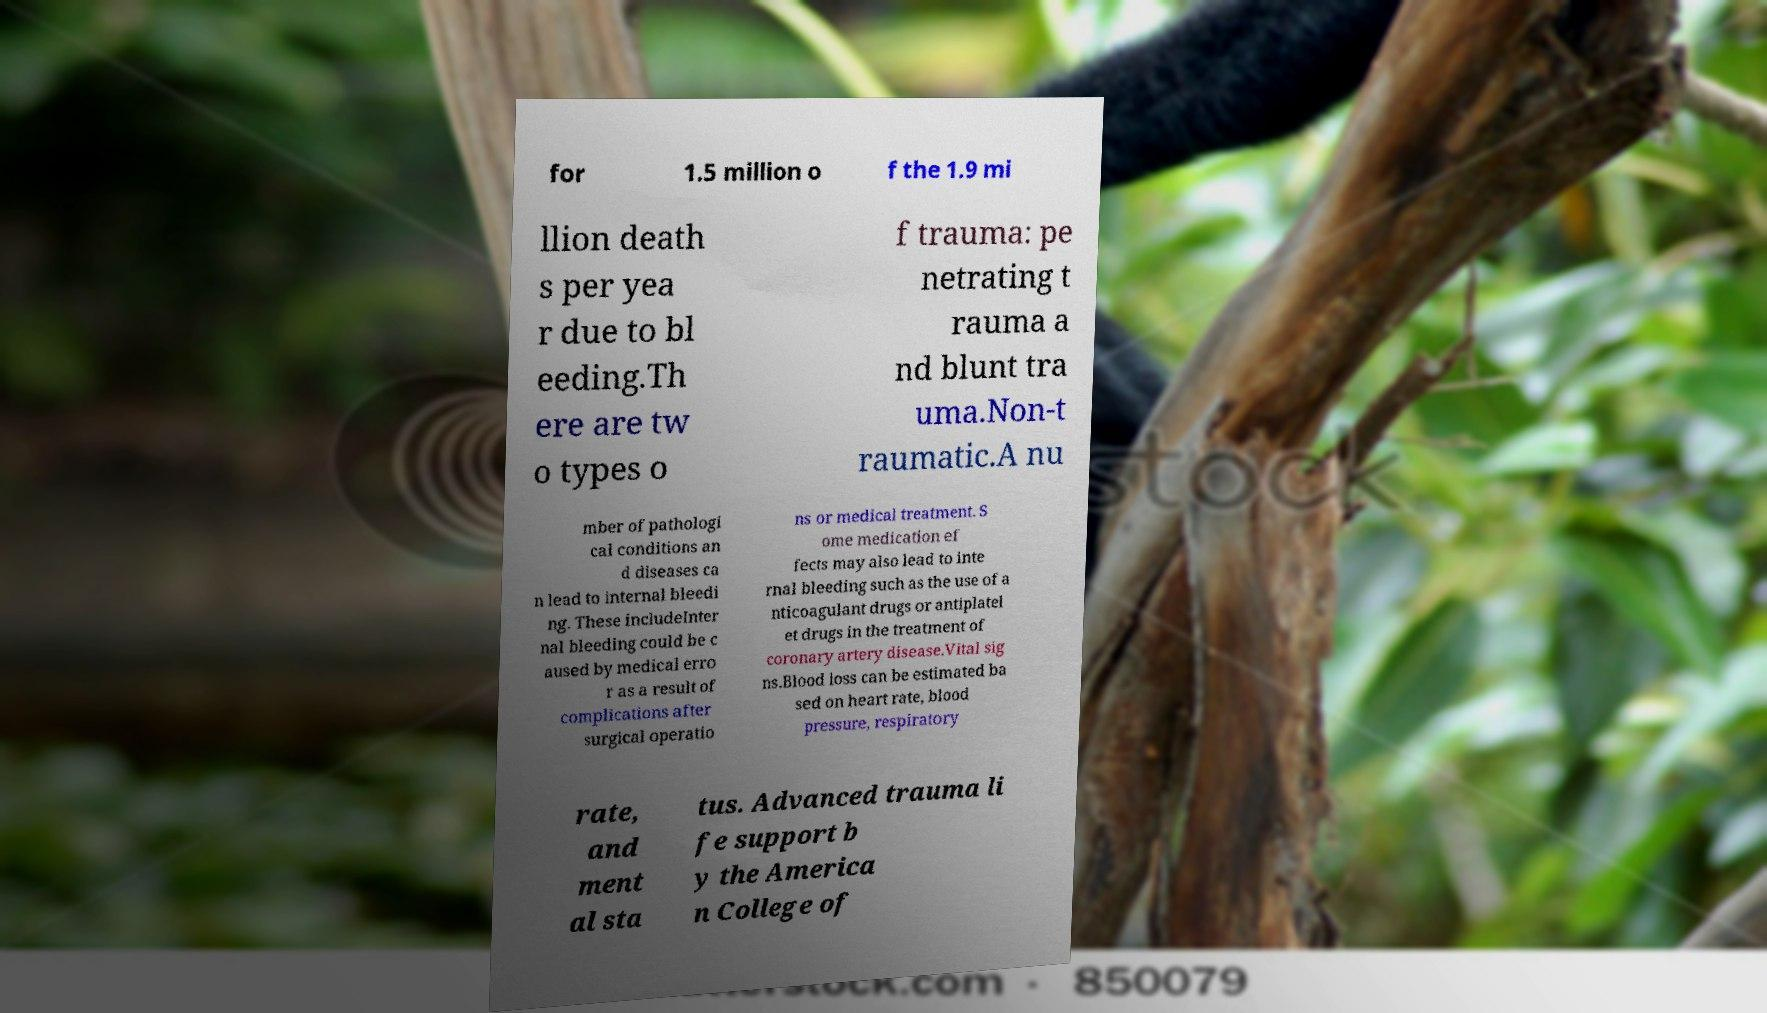What messages or text are displayed in this image? I need them in a readable, typed format. for 1.5 million o f the 1.9 mi llion death s per yea r due to bl eeding.Th ere are tw o types o f trauma: pe netrating t rauma a nd blunt tra uma.Non-t raumatic.A nu mber of pathologi cal conditions an d diseases ca n lead to internal bleedi ng. These includeInter nal bleeding could be c aused by medical erro r as a result of complications after surgical operatio ns or medical treatment. S ome medication ef fects may also lead to inte rnal bleeding such as the use of a nticoagulant drugs or antiplatel et drugs in the treatment of coronary artery disease.Vital sig ns.Blood loss can be estimated ba sed on heart rate, blood pressure, respiratory rate, and ment al sta tus. Advanced trauma li fe support b y the America n College of 